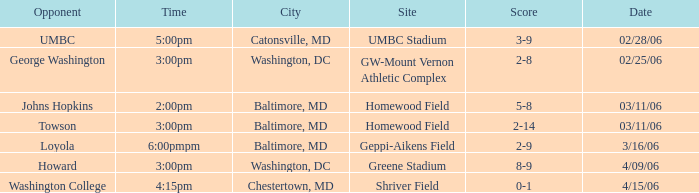What is the Date if the Site is Shriver Field? 4/15/06. 